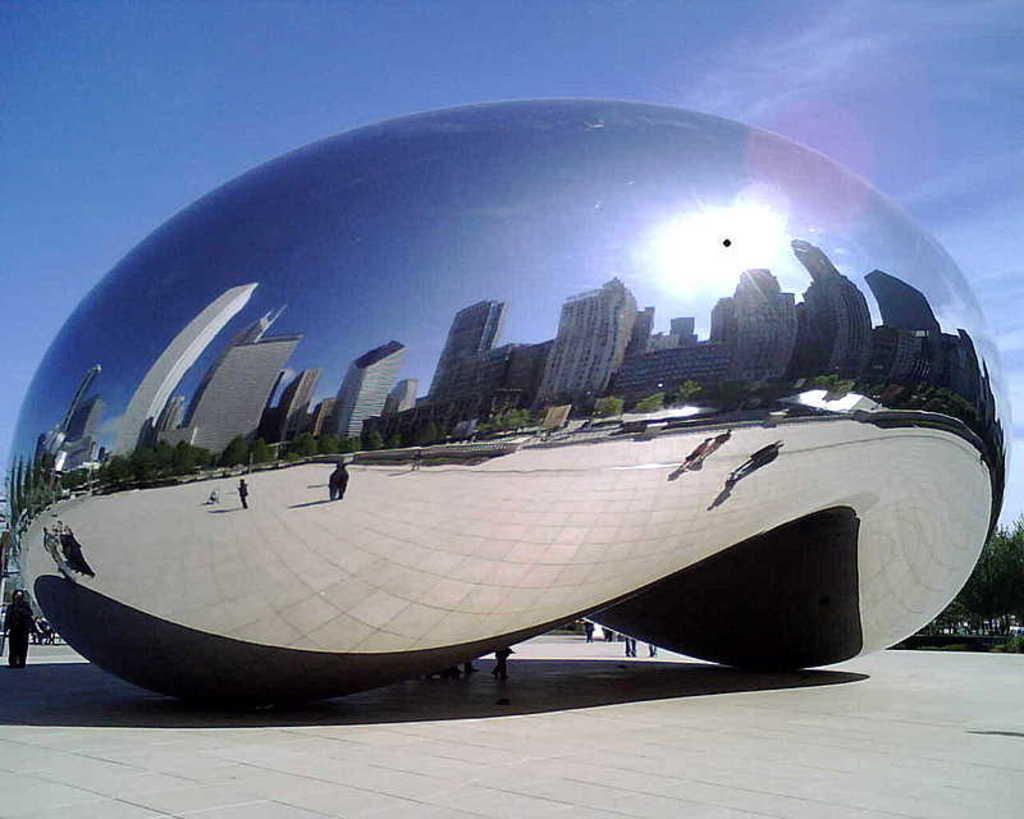In one or two sentences, can you explain what this image depicts? In the foreground of the picture we can see a construction, in the construction we can see the reflection of people, building, sky, sun and other objects. In the background it is sky. At the bottom it is floor. 